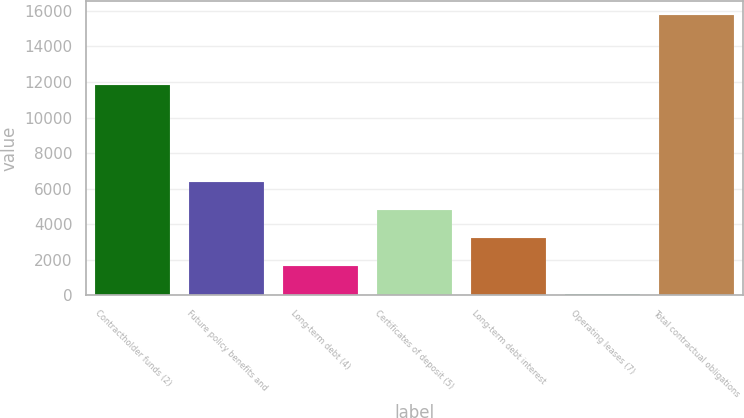Convert chart. <chart><loc_0><loc_0><loc_500><loc_500><bar_chart><fcel>Contractholder funds (2)<fcel>Future policy benefits and<fcel>Long-term debt (4)<fcel>Certificates of deposit (5)<fcel>Long-term debt interest<fcel>Operating leases (7)<fcel>Total contractual obligations<nl><fcel>11829<fcel>6354.12<fcel>1643.88<fcel>4784.04<fcel>3213.96<fcel>73.8<fcel>15774.6<nl></chart> 